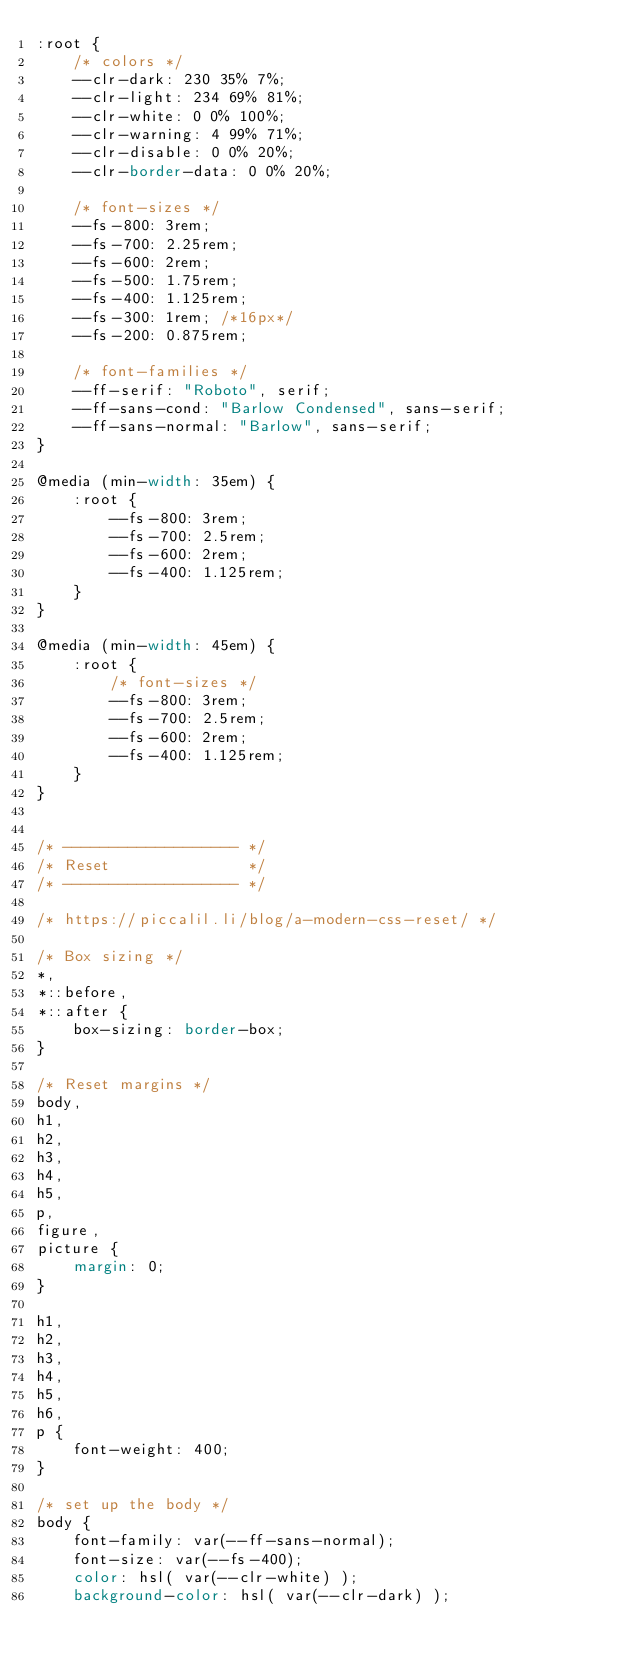Convert code to text. <code><loc_0><loc_0><loc_500><loc_500><_CSS_>:root {
    /* colors */
    --clr-dark: 230 35% 7%;
    --clr-light: 234 69% 81%;
    --clr-white: 0 0% 100%;
    --clr-warning: 4 99% 71%;
    --clr-disable: 0 0% 20%;
    --clr-border-data: 0 0% 20%;
    
    /* font-sizes */
    --fs-800: 3rem;
    --fs-700: 2.25rem;
    --fs-600: 2rem;
    --fs-500: 1.75rem;
    --fs-400: 1.125rem;
    --fs-300: 1rem; /*16px*/
    --fs-200: 0.875rem;
    
    /* font-families */
    --ff-serif: "Roboto", serif;
    --ff-sans-cond: "Barlow Condensed", sans-serif;
    --ff-sans-normal: "Barlow", sans-serif;
}

@media (min-width: 35em) {
    :root {
        --fs-800: 3rem;
        --fs-700: 2.5rem;
        --fs-600: 2rem;
        --fs-400: 1.125rem;
    }
}

@media (min-width: 45em) {
    :root {
        /* font-sizes */
        --fs-800: 3rem;
        --fs-700: 2.5rem;
        --fs-600: 2rem;
        --fs-400: 1.125rem;
    }
}


/* ------------------- */
/* Reset               */
/* ------------------- */

/* https://piccalil.li/blog/a-modern-css-reset/ */

/* Box sizing */
*,
*::before,
*::after {
    box-sizing: border-box;
}

/* Reset margins */
body,
h1,
h2,
h3,
h4,
h5,
p,
figure,
picture {
    margin: 0; 
}

h1,
h2,
h3,
h4,
h5,
h6,
p {
    font-weight: 400;
}

/* set up the body */
body {
    font-family: var(--ff-sans-normal);
    font-size: var(--fs-400);
    color: hsl( var(--clr-white) );
    background-color: hsl( var(--clr-dark) );</code> 